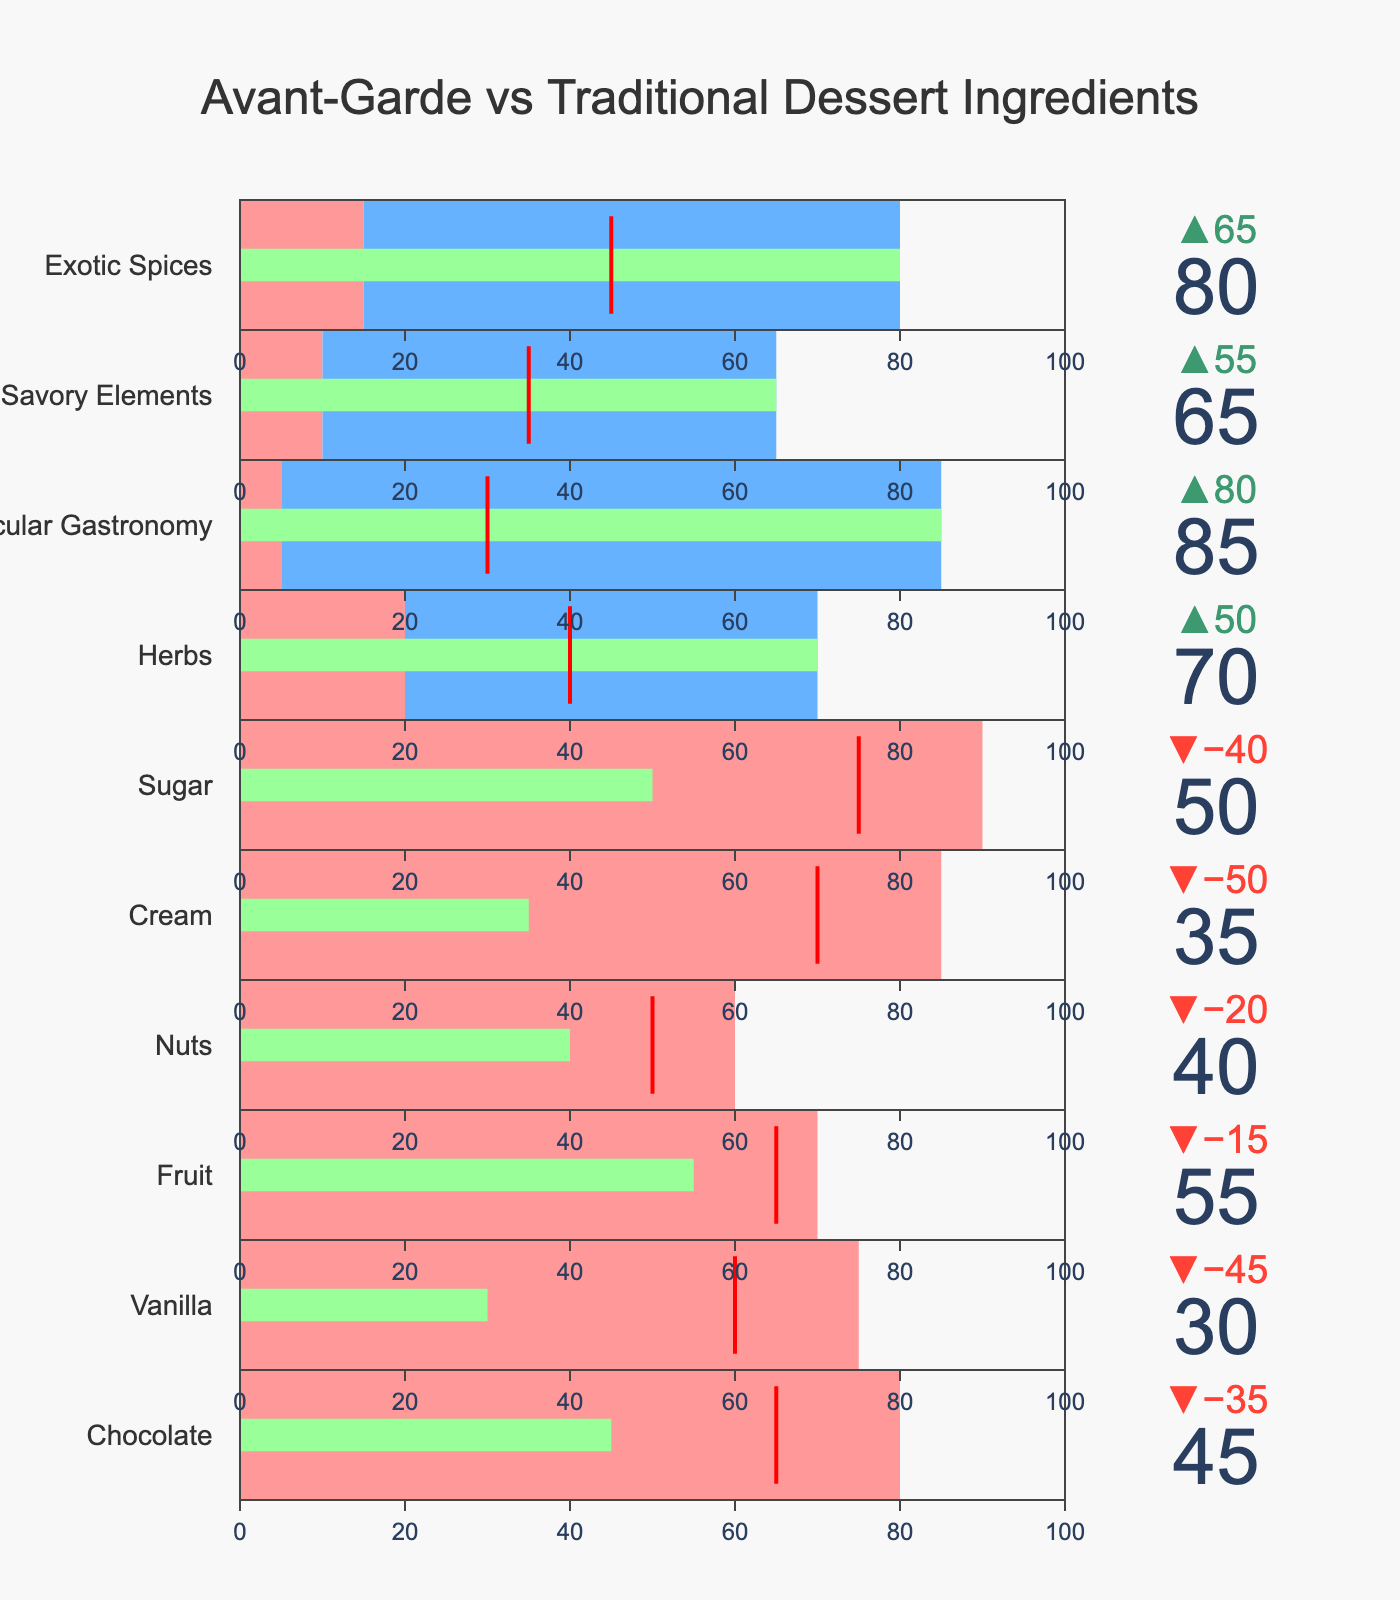What is the title of the chart? The title is displayed at the top of the chart in a larger font, clearly stating the overall subject matter.
Answer: Avant-Garde vs Traditional Dessert Ingredients Which ingredient has the highest usage in traditional desserts? By examining the bullet sections labeled for "Traditional" usage, it is evident that one category reaches the highest value.
Answer: Sugar How many ingredients have higher usage in avant-garde desserts compared to traditional desserts? By scanning the values for each category and comparing the "Traditional" usage to the "Avant-Garde" usage, count the categories where the latter is greater.
Answer: 4 For which ingredient is the traditional usage closest to the benchmark? Locate the benchmark line for each category and compare distances to the "Traditional" values, identifying the one closest.
Answer: Nuts How much more is sugar used in traditional desserts compared to avant-garde desserts? Subtract the "Avant-Garde" value for sugar from the "Traditional" value: 90 (Traditional) - 50 (Avant-Garde) = 40.
Answer: 40 Which ingredient has the largest discrepancy between its traditional and avant-garde usage? Calculate the difference for each ingredient and identify the one with the largest difference: subtract the values for each ingredient and compare.
Answer: Molecular Gastronomy What is the average usage of chocolate and vanilla in avant-garde desserts? Add the "Avant-Garde" values for chocolate and vanilla, then divide by 2: (45 + 30) / 2 = 37.5.
Answer: 37.5 What ingredient shows a significant shift towards avant-garde desserts with low traditional usage? Identify the ingredient in the chart that has a low "Traditional" usage and a high "Avant-Garde" usage, showing a clear shift.
Answer: Molecular Gastronomy Which traditional ingredient is used more broadly compared to its avant-garde counterpart based on its bar color? Look at the bars colored for "Traditional" values and identify which one extends significantly farther than its "Avant-Garde" counterpart.
Answer: Cream How much more is vanilla used in traditional desserts compared to the benchmark? Subtract the benchmark value for vanilla from the "Traditional" usage: 75 (Traditional) - 60 (Benchmark) = 15.
Answer: 15 